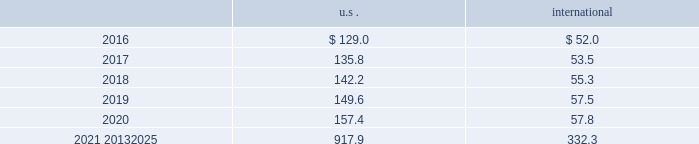Mutual and pooled funds shares of mutual funds are valued at the net asset value ( nav ) quoted on the exchange where the fund is traded and are classified as level 1 assets .
Units of pooled funds are valued at the per unit nav determined by the fund manager and are classified as level 2 assets .
The investments are utilizing nav as a practical expedient for fair value .
Corporate and government bonds corporate and government bonds are classified as level 2 assets , as they are either valued at quoted market prices from observable pricing sources at the reporting date or valued based upon comparable securities with similar yields and credit ratings .
Mortgage and asset-backed securities mortgage and asset 2013backed securities are classified as level 2 assets , as they are either valued at quoted market prices from observable pricing sources at the reporting date or valued based upon comparable securities with similar yields , credit ratings , and purpose of the underlying loan .
Real estate pooled funds real estate pooled funds are classified as level 3 assets , as they are carried at the estimated fair value of the underlying properties .
Estimated fair value is calculated utilizing a combination of key inputs , such as revenue and expense growth rates , terminal capitalization rates , and discount rates .
These key inputs are consistent with practices prevailing within the real estate investment management industry .
Other pooled funds other pooled funds classified as level 2 assets are valued at the nav of the shares held at year end , which is based on the fair value of the underlying investments .
Securities and interests classified as level 3 are carried at the estimated fair value of the underlying investments .
The underlying investments are valued based on bids from brokers or other third-party vendor sources that utilize expected cash flow streams and other uncorroborated data , including counterparty credit quality , default risk , discount rates , and the overall capital market liquidity .
Insurance contracts insurance contracts are classified as level 3 assets , as they are carried at contract value , which approximates the estimated fair value .
The estimated fair value is based on the fair value of the underlying investment of the insurance company .
Contributions and projected benefit payments pension contributions to funded plans and benefit payments for unfunded plans for fiscal year 2015 were $ 137.5 .
Contributions resulted primarily from an assessment of long-term funding requirements of the plans and tax planning .
Benefit payments to unfunded plans were due primarily to the timing of retirements and cost reduction actions .
We anticipate contributing $ 100 to $ 120 to the defined benefit pension plans in 2016 .
These contributions are driven primarily by benefit payments for unfunded plans , which are dependent upon timing of retirements and actions to reorganize the business .
Projected benefit payments , which reflect expected future service , are as follows: .
These estimated benefit payments are based on assumptions about future events .
Actual benefit payments may vary significantly from these estimates. .
Considering the average for the years 2021-2025 , what is the increase observed in the projected benefit payments for the u.s during 2020 and 2021? 
Rationale: it is the 2021 projected benefit payment divided by the 2020s , which is calculated through the average formula , then turned into a percentage.\\n
Computations: (((917.9 / 5) / 157.4) - 1)
Answer: 0.16633. 